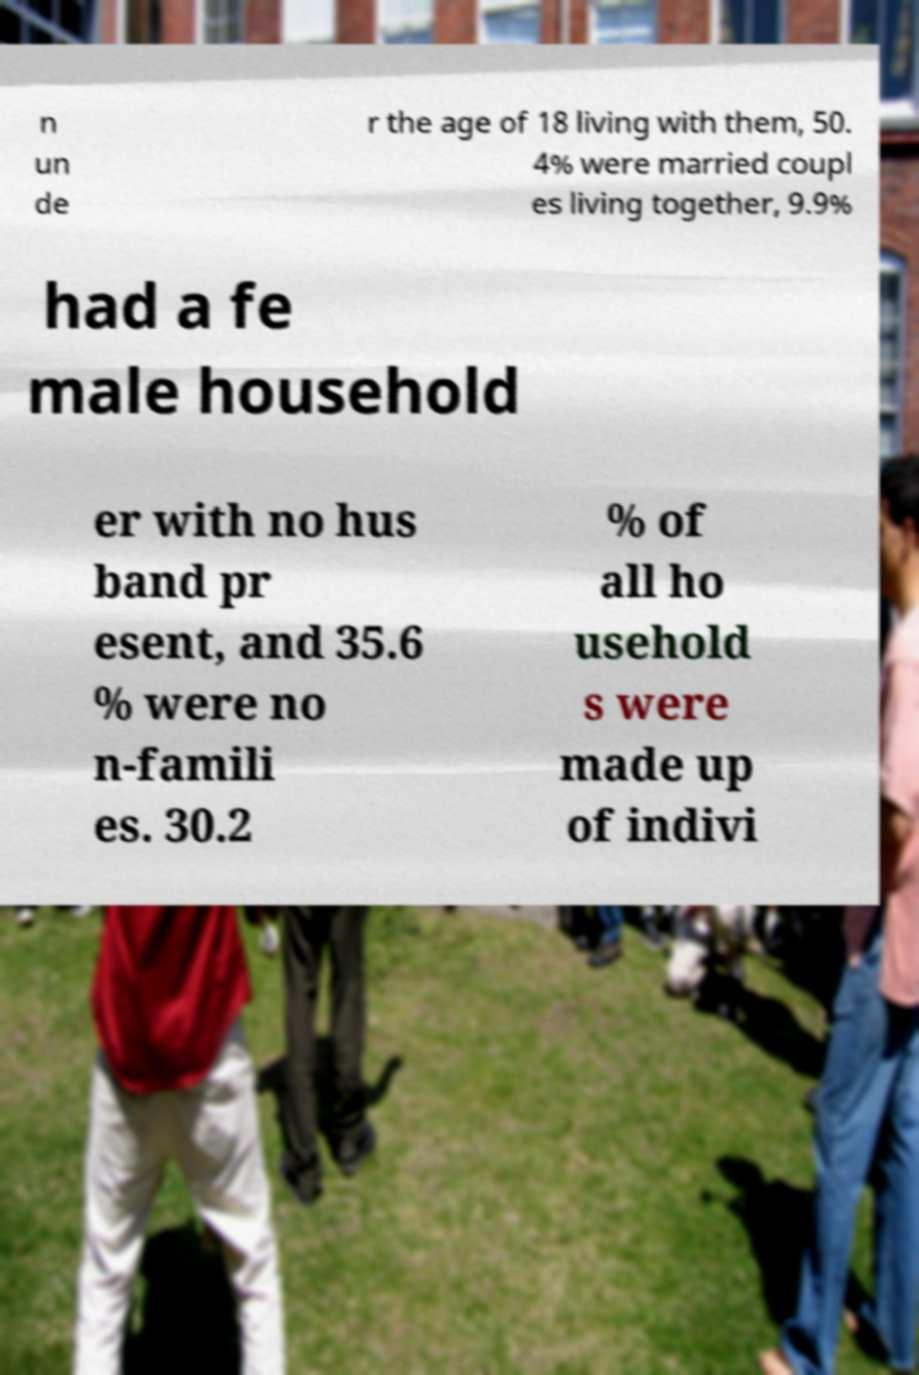What messages or text are displayed in this image? I need them in a readable, typed format. n un de r the age of 18 living with them, 50. 4% were married coupl es living together, 9.9% had a fe male household er with no hus band pr esent, and 35.6 % were no n-famili es. 30.2 % of all ho usehold s were made up of indivi 